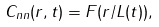Convert formula to latex. <formula><loc_0><loc_0><loc_500><loc_500>C _ { n n } ( { r } , t ) = F ( r / L ( t ) ) ,</formula> 